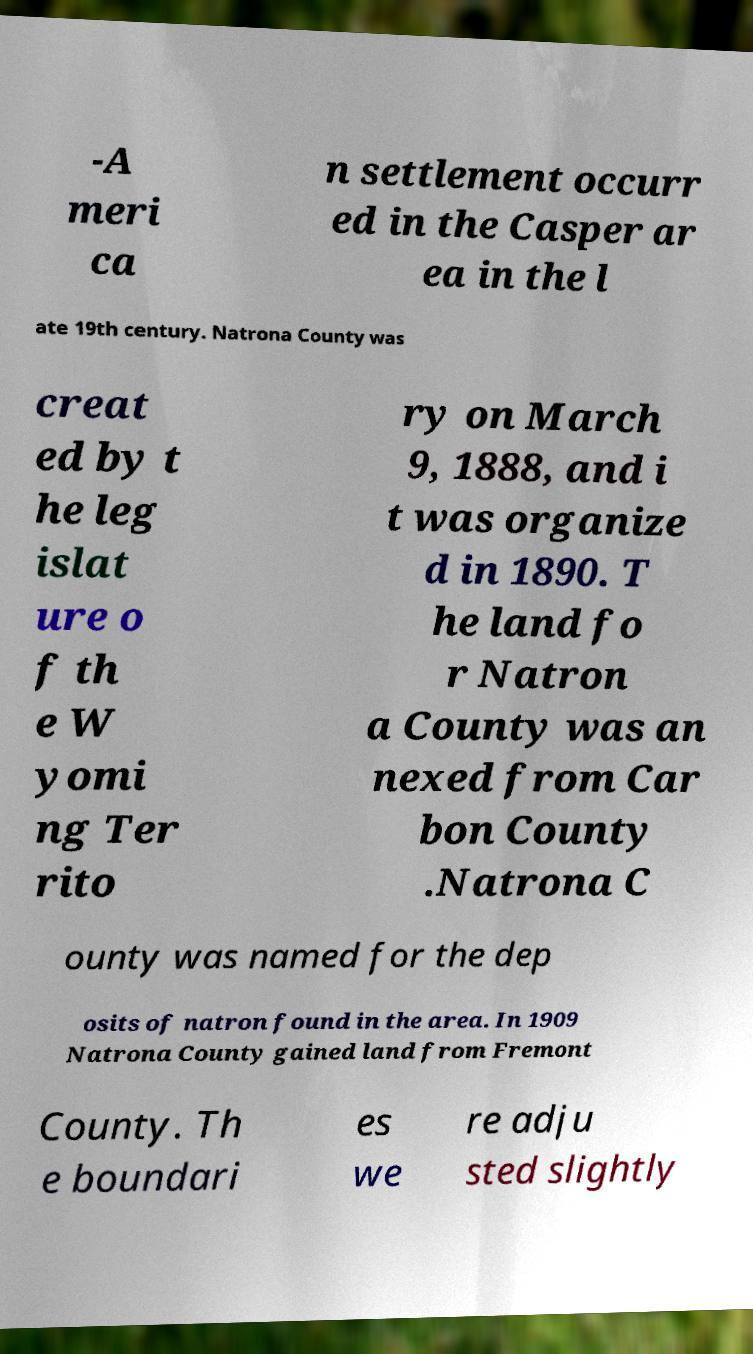What messages or text are displayed in this image? I need them in a readable, typed format. -A meri ca n settlement occurr ed in the Casper ar ea in the l ate 19th century. Natrona County was creat ed by t he leg islat ure o f th e W yomi ng Ter rito ry on March 9, 1888, and i t was organize d in 1890. T he land fo r Natron a County was an nexed from Car bon County .Natrona C ounty was named for the dep osits of natron found in the area. In 1909 Natrona County gained land from Fremont County. Th e boundari es we re adju sted slightly 